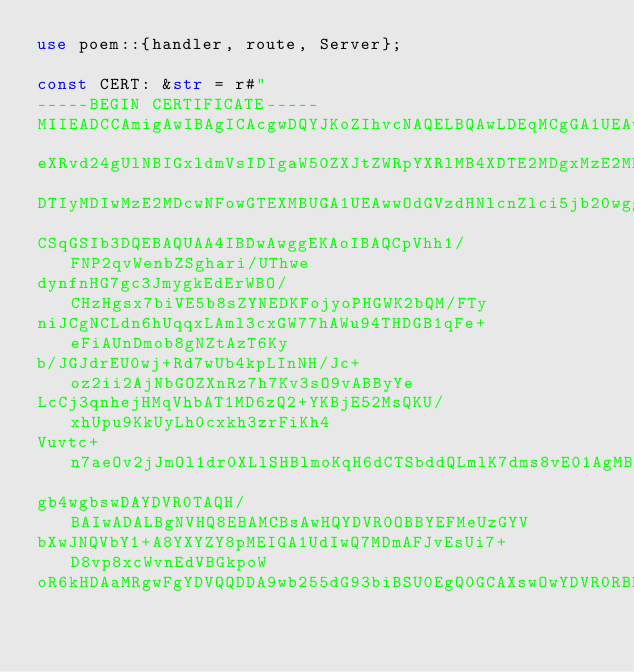<code> <loc_0><loc_0><loc_500><loc_500><_Rust_>use poem::{handler, route, Server};

const CERT: &str = r#"
-----BEGIN CERTIFICATE-----
MIIEADCCAmigAwIBAgICAcgwDQYJKoZIhvcNAQELBQAwLDEqMCgGA1UEAwwhcG9u
eXRvd24gUlNBIGxldmVsIDIgaW50ZXJtZWRpYXRlMB4XDTE2MDgxMzE2MDcwNFoX
DTIyMDIwMzE2MDcwNFowGTEXMBUGA1UEAwwOdGVzdHNlcnZlci5jb20wggEiMA0G
CSqGSIb3DQEBAQUAA4IBDwAwggEKAoIBAQCpVhh1/FNP2qvWenbZSghari/UThwe
dynfnHG7gc3JmygkEdErWBO/CHzHgsx7biVE5b8sZYNEDKFojyoPHGWK2bQM/FTy
niJCgNCLdn6hUqqxLAml3cxGW77hAWu94THDGB1qFe+eFiAUnDmob8gNZtAzT6Ky
b/JGJdrEU0wj+Rd7wUb4kpLInNH/Jc+oz2ii2AjNbGOZXnRz7h7Kv3sO9vABByYe
LcCj3qnhejHMqVhbAT1MD6zQ2+YKBjE52MsQKU/xhUpu9KkUyLh0cxkh3zrFiKh4
Vuvtc+n7aeOv2jJmOl1dr0XLlSHBlmoKqH6dCTSbddQLmlK7dms8vE01AgMBAAGj
gb4wgbswDAYDVR0TAQH/BAIwADALBgNVHQ8EBAMCBsAwHQYDVR0OBBYEFMeUzGYV
bXwJNQVbY1+A8YXYZY8pMEIGA1UdIwQ7MDmAFJvEsUi7+D8vp8xcWvnEdVBGkpoW
oR6kHDAaMRgwFgYDVQQDDA9wb255dG93biBSU0EgQ0GCAXswOwYDVR0RBDQwMoIO</code> 